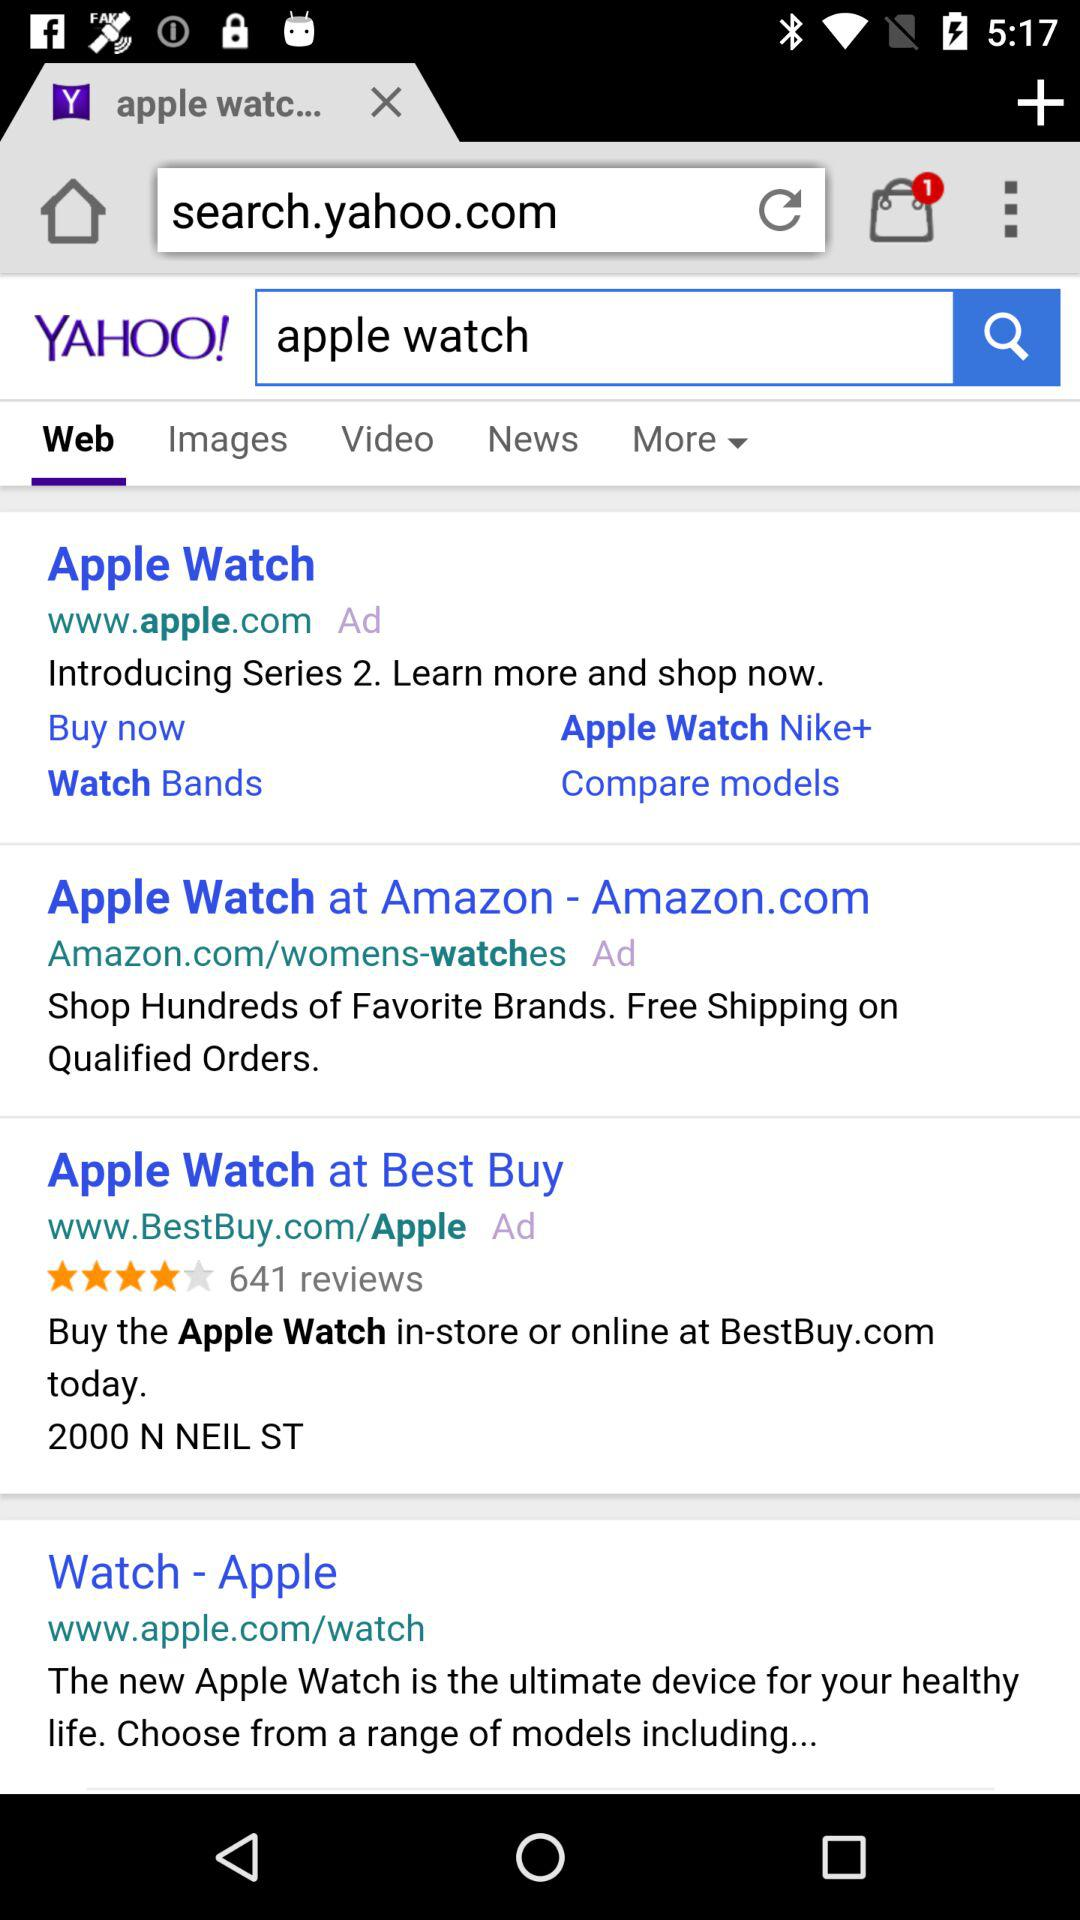How many results are there for the search term apple watch?
Answer the question using a single word or phrase. 4 